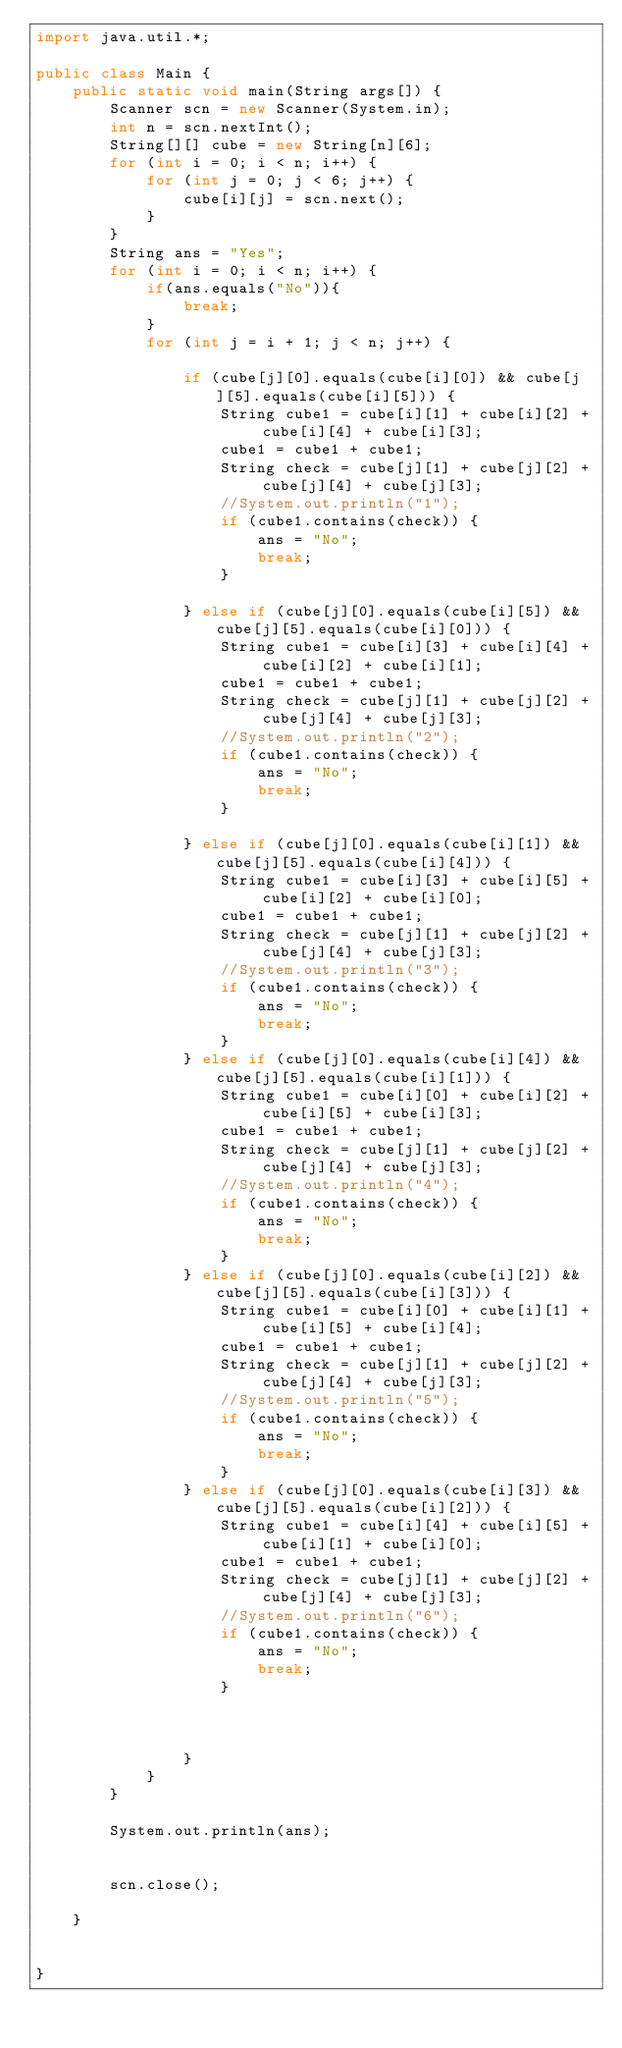<code> <loc_0><loc_0><loc_500><loc_500><_Java_>import java.util.*;

public class Main {
    public static void main(String args[]) {
        Scanner scn = new Scanner(System.in);
        int n = scn.nextInt();
        String[][] cube = new String[n][6];
        for (int i = 0; i < n; i++) {
            for (int j = 0; j < 6; j++) {
                cube[i][j] = scn.next();
            }
        }
        String ans = "Yes";
        for (int i = 0; i < n; i++) {
            if(ans.equals("No")){
                break;
            }
            for (int j = i + 1; j < n; j++) {

                if (cube[j][0].equals(cube[i][0]) && cube[j][5].equals(cube[i][5])) {
                    String cube1 = cube[i][1] + cube[i][2] + cube[i][4] + cube[i][3];
                    cube1 = cube1 + cube1;
                    String check = cube[j][1] + cube[j][2] + cube[j][4] + cube[j][3];
                    //System.out.println("1");
                    if (cube1.contains(check)) {
                        ans = "No";
                        break;
                    }

                } else if (cube[j][0].equals(cube[i][5]) && cube[j][5].equals(cube[i][0])) {
                    String cube1 = cube[i][3] + cube[i][4] + cube[i][2] + cube[i][1];
                    cube1 = cube1 + cube1;
                    String check = cube[j][1] + cube[j][2] + cube[j][4] + cube[j][3];
                    //System.out.println("2");
                    if (cube1.contains(check)) {
                        ans = "No";
                        break;
                    }

                } else if (cube[j][0].equals(cube[i][1]) && cube[j][5].equals(cube[i][4])) {
                    String cube1 = cube[i][3] + cube[i][5] + cube[i][2] + cube[i][0];
                    cube1 = cube1 + cube1;
                    String check = cube[j][1] + cube[j][2] + cube[j][4] + cube[j][3];
                    //System.out.println("3");
                    if (cube1.contains(check)) {
                        ans = "No";
                        break;
                    }
                } else if (cube[j][0].equals(cube[i][4]) && cube[j][5].equals(cube[i][1])) {
                    String cube1 = cube[i][0] + cube[i][2] + cube[i][5] + cube[i][3];
                    cube1 = cube1 + cube1;
                    String check = cube[j][1] + cube[j][2] + cube[j][4] + cube[j][3];
                    //System.out.println("4");
                    if (cube1.contains(check)) {
                        ans = "No";
                        break;
                    }
                } else if (cube[j][0].equals(cube[i][2]) && cube[j][5].equals(cube[i][3])) {
                    String cube1 = cube[i][0] + cube[i][1] + cube[i][5] + cube[i][4];
                    cube1 = cube1 + cube1;
                    String check = cube[j][1] + cube[j][2] + cube[j][4] + cube[j][3];
                    //System.out.println("5");
                    if (cube1.contains(check)) {
                        ans = "No";
                        break;
                    }
                } else if (cube[j][0].equals(cube[i][3]) && cube[j][5].equals(cube[i][2])) {
                    String cube1 = cube[i][4] + cube[i][5] + cube[i][1] + cube[i][0];
                    cube1 = cube1 + cube1;
                    String check = cube[j][1] + cube[j][2] + cube[j][4] + cube[j][3];
                    //System.out.println("6");
                    if (cube1.contains(check)) {
                        ans = "No";
                        break;
                    }



                }
            }
        }

        System.out.println(ans);


        scn.close();

    }


}

</code> 